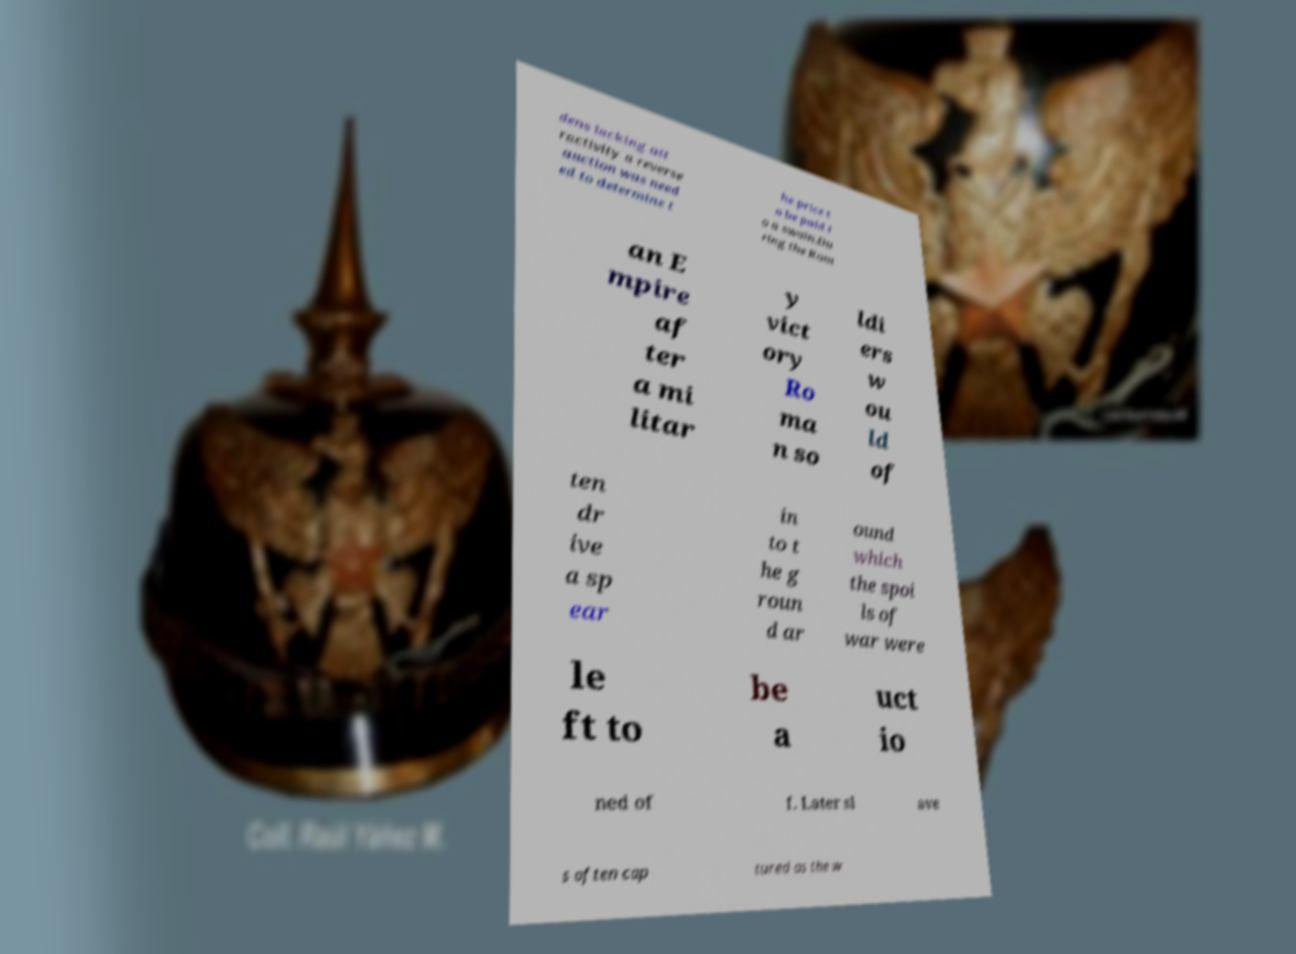What messages or text are displayed in this image? I need them in a readable, typed format. dens lacking att ractivity a reverse auction was need ed to determine t he price t o be paid t o a swain.Du ring the Rom an E mpire af ter a mi litar y vict ory Ro ma n so ldi ers w ou ld of ten dr ive a sp ear in to t he g roun d ar ound which the spoi ls of war were le ft to be a uct io ned of f. Later sl ave s often cap tured as the w 